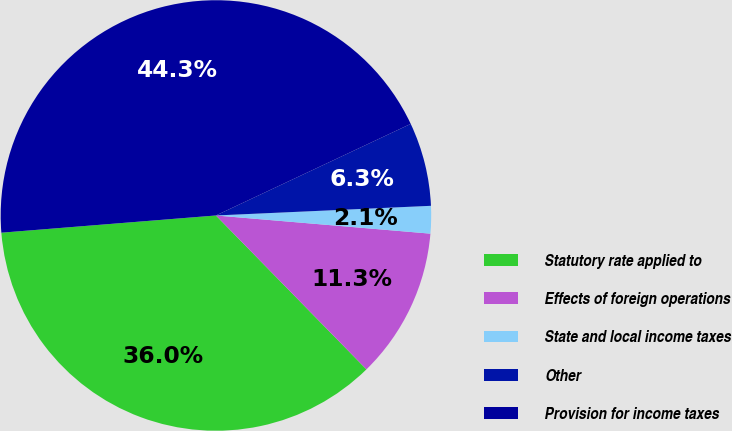<chart> <loc_0><loc_0><loc_500><loc_500><pie_chart><fcel>Statutory rate applied to<fcel>Effects of foreign operations<fcel>State and local income taxes<fcel>Other<fcel>Provision for income taxes<nl><fcel>36.05%<fcel>11.33%<fcel>2.06%<fcel>6.28%<fcel>44.28%<nl></chart> 